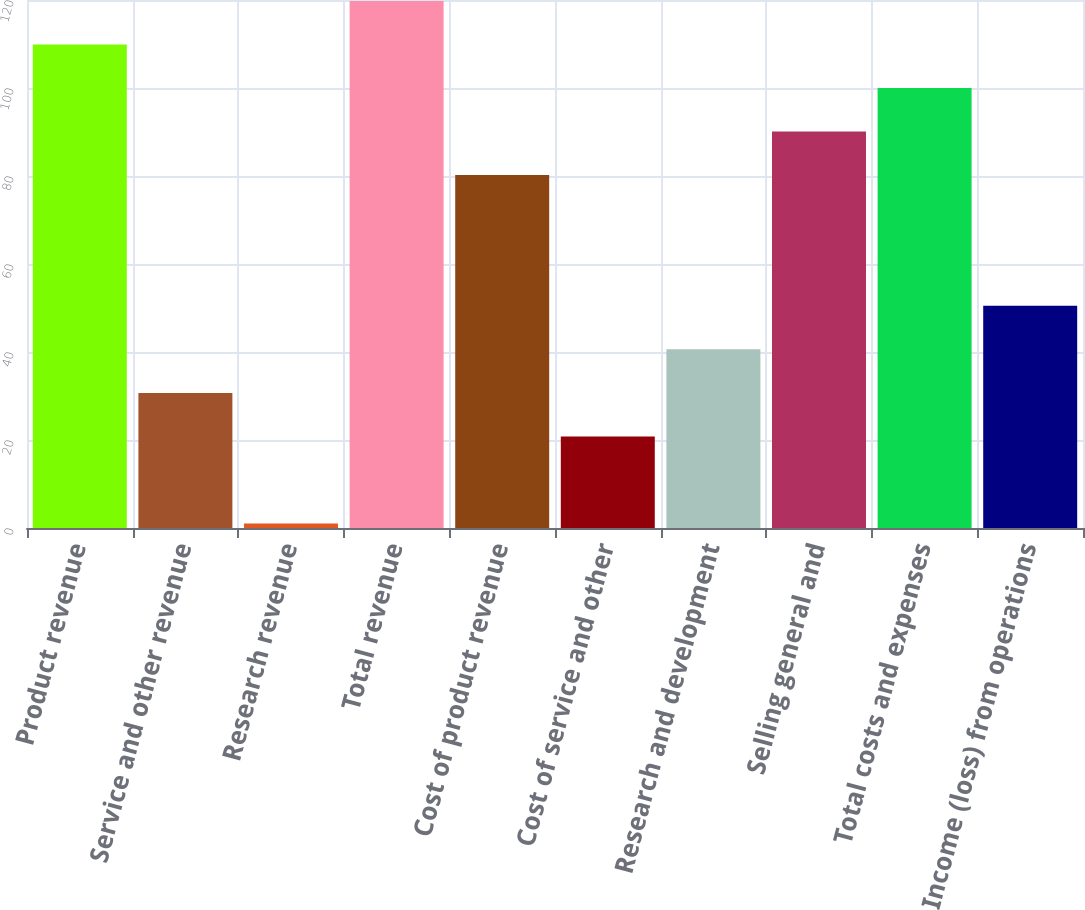Convert chart. <chart><loc_0><loc_0><loc_500><loc_500><bar_chart><fcel>Product revenue<fcel>Service and other revenue<fcel>Research revenue<fcel>Total revenue<fcel>Cost of product revenue<fcel>Cost of service and other<fcel>Research and development<fcel>Selling general and<fcel>Total costs and expenses<fcel>Income (loss) from operations<nl><fcel>109.9<fcel>30.7<fcel>1<fcel>119.8<fcel>80.2<fcel>20.8<fcel>40.6<fcel>90.1<fcel>100<fcel>50.5<nl></chart> 